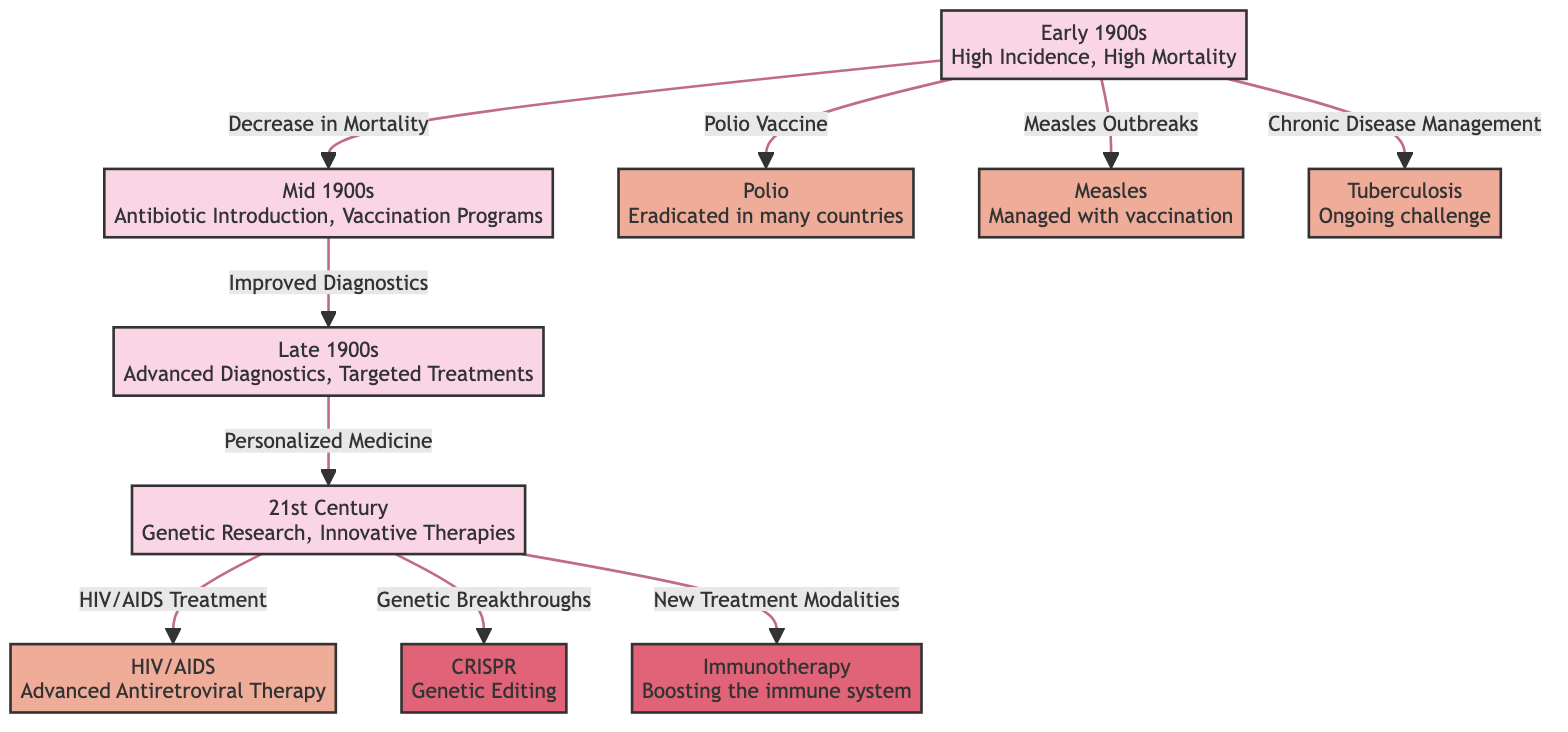What decade saw the introduction of antibiotics? The diagram illustrates that the introduction of antibiotics occurred during the "Mid 1900s" era, as denoted by the arrow connecting the early 1900s to the mid 1900s node.
Answer: Mid 1900s How many major eras are represented in this diagram? The diagram contains four distinct eras shown: Early 1900s, Mid 1900s, Late 1900s, and 21st Century. Therefore, counting each of these gives a total of four eras.
Answer: 4 What disease was eradicated in many countries? The flowchart identifies polio as a disease that has been eradicated in many countries, as indicated by the specific node labeled for polio.
Answer: Polio Which treatment is associated with genetic breakthroughs? According to the diagram, CRISPR, described as genetic editing, is linked to genetic breakthroughs in the 21st Century era, represented by an arrow connecting the two nodes.
Answer: CRISPR What is the relationship between the Early 1900s and Mid 1900s regarding mortality? The relationship between these two eras in the diagram is described as a "Decrease in Mortality," indicating an improvement in the health outcomes by the mid-1900s compared to the early 1900s.
Answer: Decrease in Mortality How has the approach to tuberculosis changed over time? The diagram indicates that tuberculosis remains "an ongoing challenge" from the Early 1900s to the present, with no specific treatment innovations mentioned, highlighting its persistent status as a problem faced in both earlier and later eras.
Answer: Ongoing challenge Which innovative therapy relates to boosting the immune system? From the diagram, immunotherapy is shown as a treatment modality that is used to boost the immune system, as indicated by the portion of the diagram focused on new treatment innovations in the 21st Century.
Answer: Immunotherapy What major transition occurred from the Late 1900s to the 21st Century? The diagram shows that the transition involved moving from "Advanced Diagnostics, Targeted Treatments" to "Genetic Research, Innovative Therapies," signifying a shift towards genetic and novel therapeutic approaches.
Answer: Personalized Medicine What major disease is associated with advanced antiretroviral therapy? The diagram specifically associates the disease HIV/AIDS with advanced antiretroviral therapy, as highlighted in the 21st Century era.
Answer: HIV/AIDS 